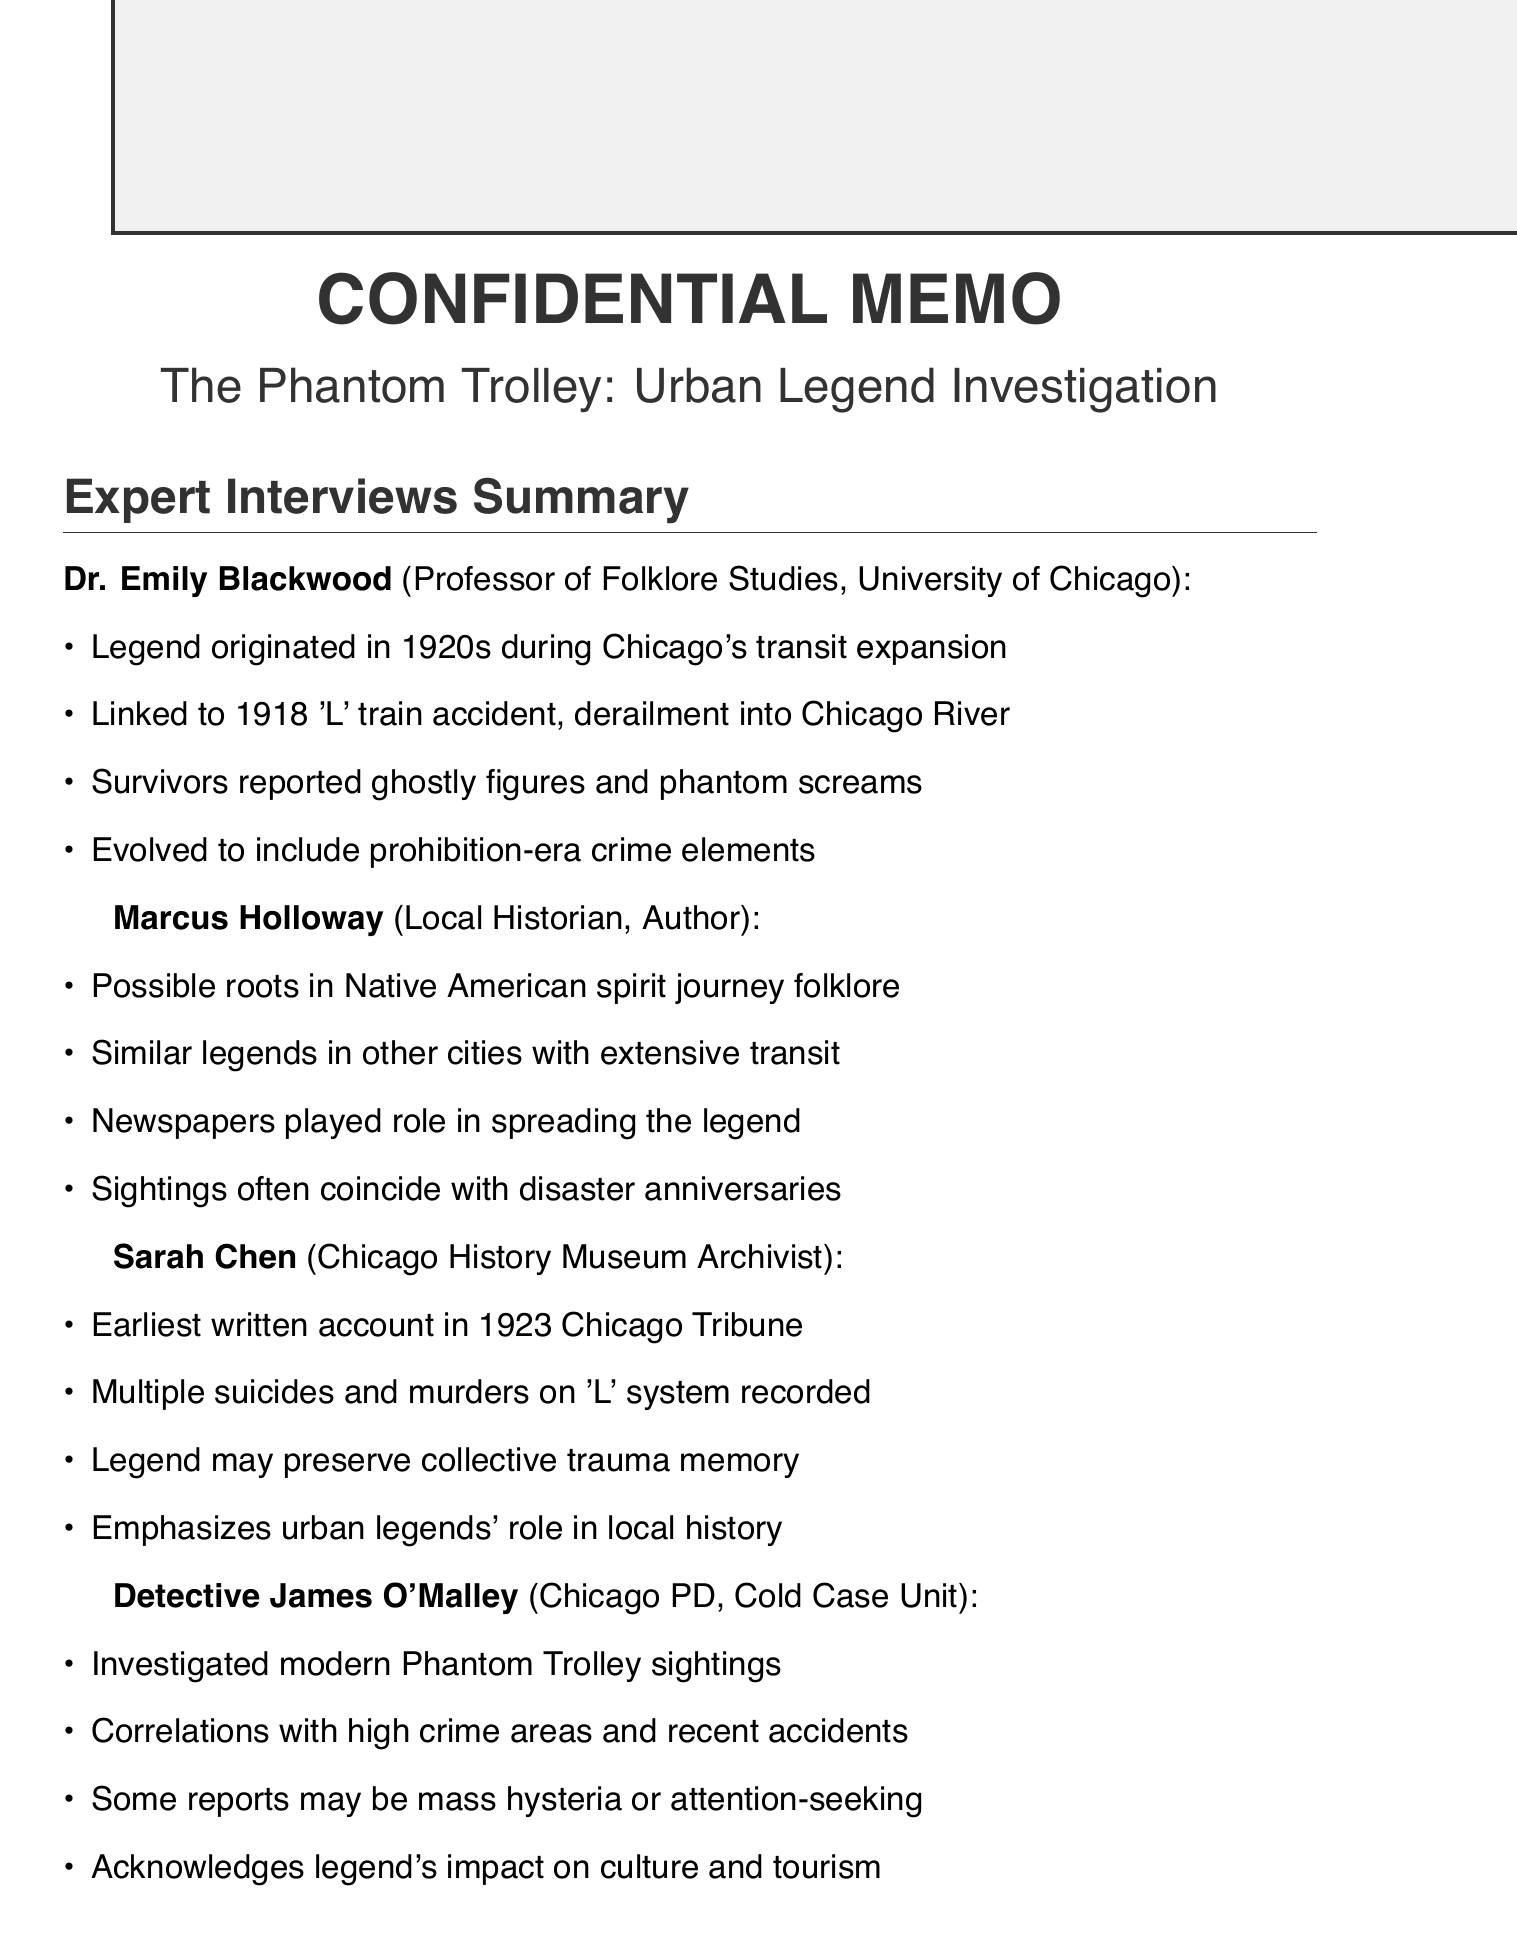What decade did the "Phantom Trolley" legend originate? The "Phantom Trolley" legend originated in the 1920s, as mentioned in Dr. Emily Blackwood's summary.
Answer: 1920s Who investigated modern sightings of the Phantom Trolley? Detective James O'Malley from the Chicago Police Department's Cold Case Unit investigated modern sightings.
Answer: Detective James O'Malley What tragic event is linked to the origins of the legend? The legend is linked to the 1918 'L' train accident where a trolley derailed and fell into the Chicago River.
Answer: 1918 'L' train accident In what year was the earliest written account found? The earliest written account of the Phantom Trolley was found in a 1923 Chicago Tribune article.
Answer: 1923 What does Marcus Holloway suggest about the roots of the legend? Marcus Holloway suggests that the legend may have roots in Native American folklore about spirit journeys.
Answer: Native American folklore What psychological functions do urban legends serve, according to the document? The document notes that urban legends serve psychological and sociological functions.
Answer: Psychological and sociological functions What key role do newspapers play in the legend's evolution? Newspapers played a role in spreading and embellishing the Phantom Trolley legend, as highlighted by Marcus Holloway.
Answer: Spreading and embellishing How many common themes are listed in the document? The document lists five common themes related to the Phantom Trolley legend.
Answer: Five What is the title of the article authored by Marcus Holloway? Marcus Holloway is the author of "Chicago's Ghostly Past."
Answer: Chicago's Ghostly Past 